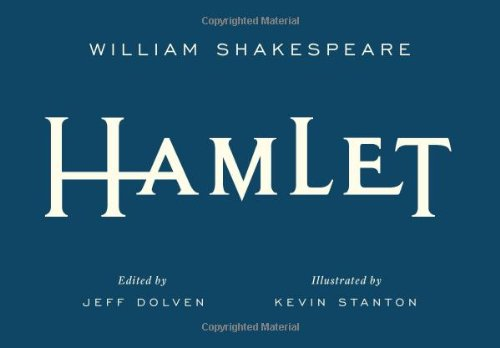Is this book related to Education & Teaching? No, while 'Hamlet' can be used as an educational tool in literature courses, it is not specifically categorised under Education & Teaching as its primary genre. 